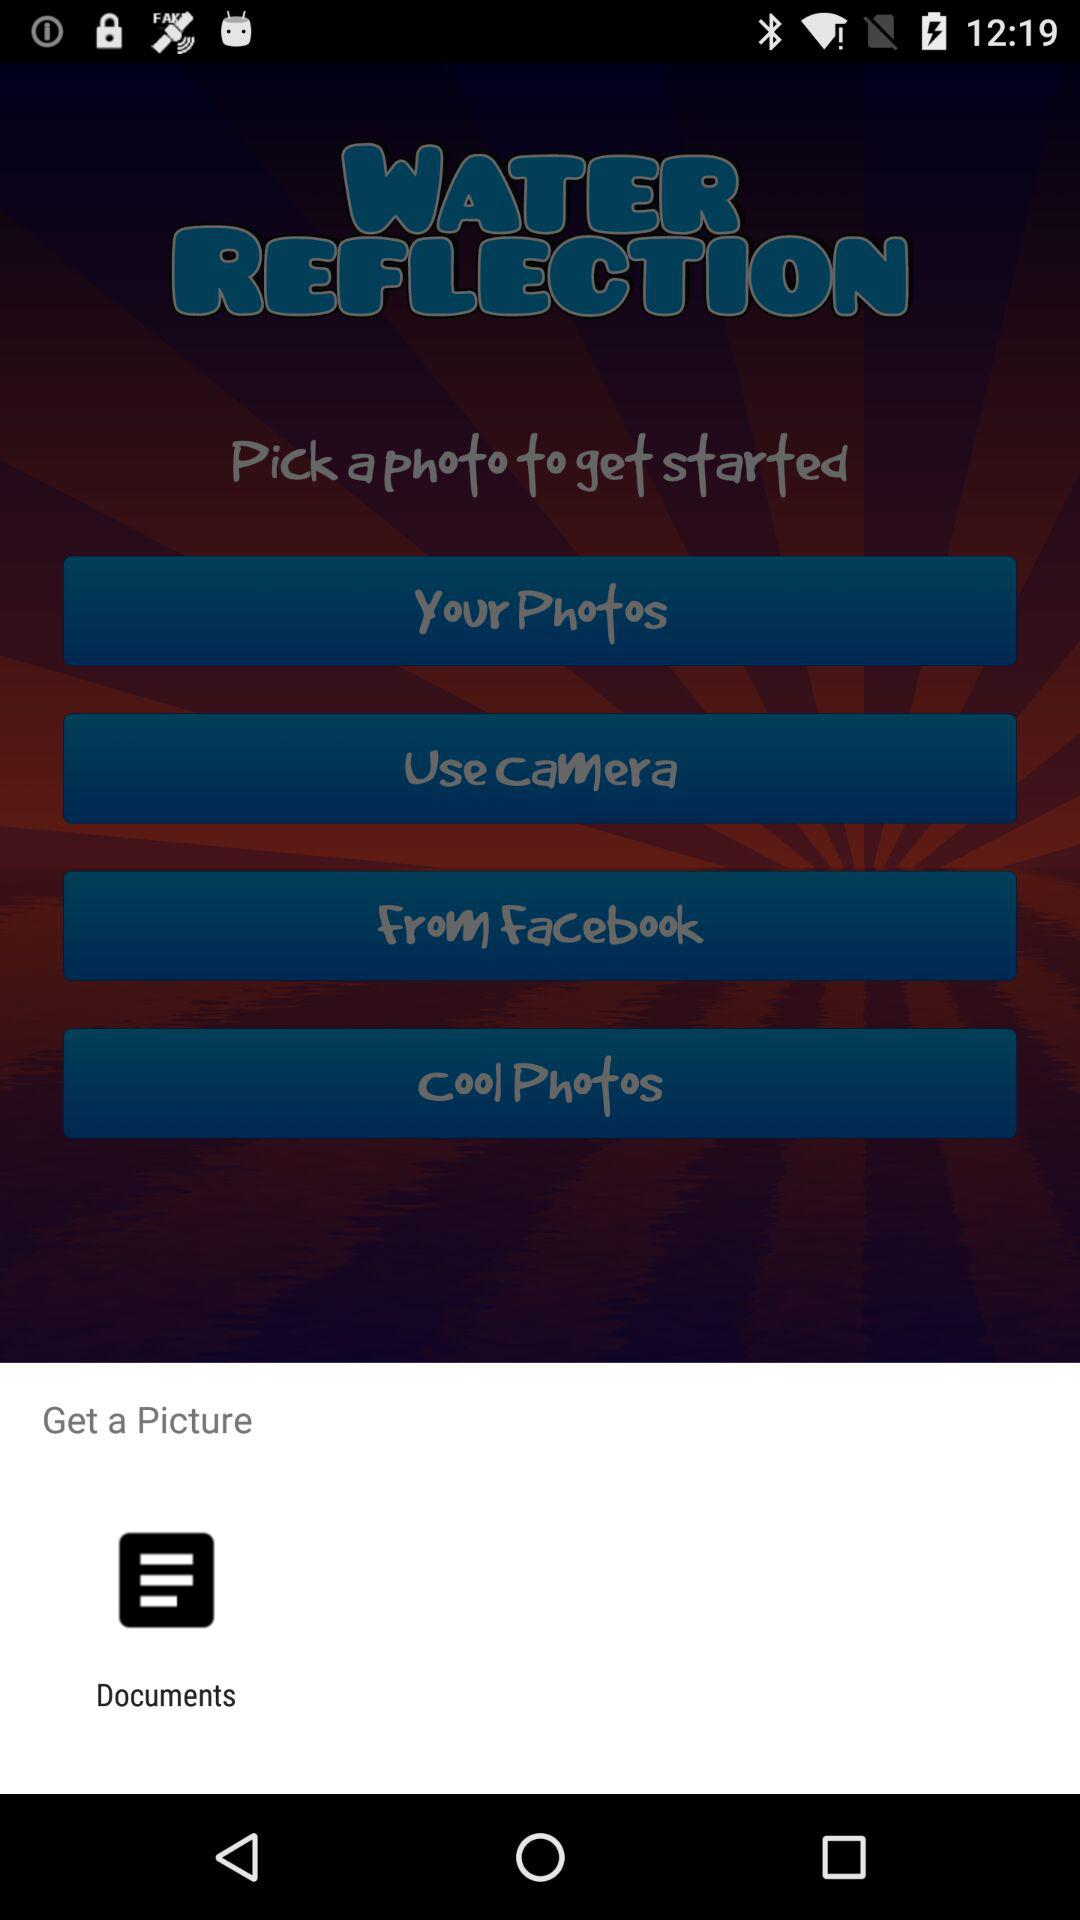By what app can we get a picture? You can get a picture by "Documents". 